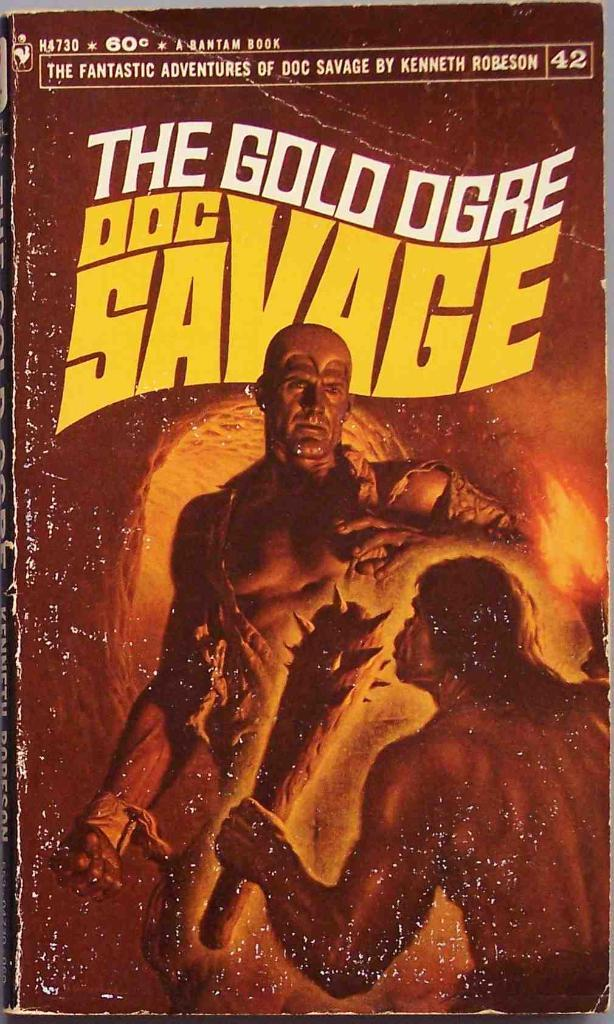<image>
Offer a succinct explanation of the picture presented. A book by Kenneth Robeson shows two men on the cover. 